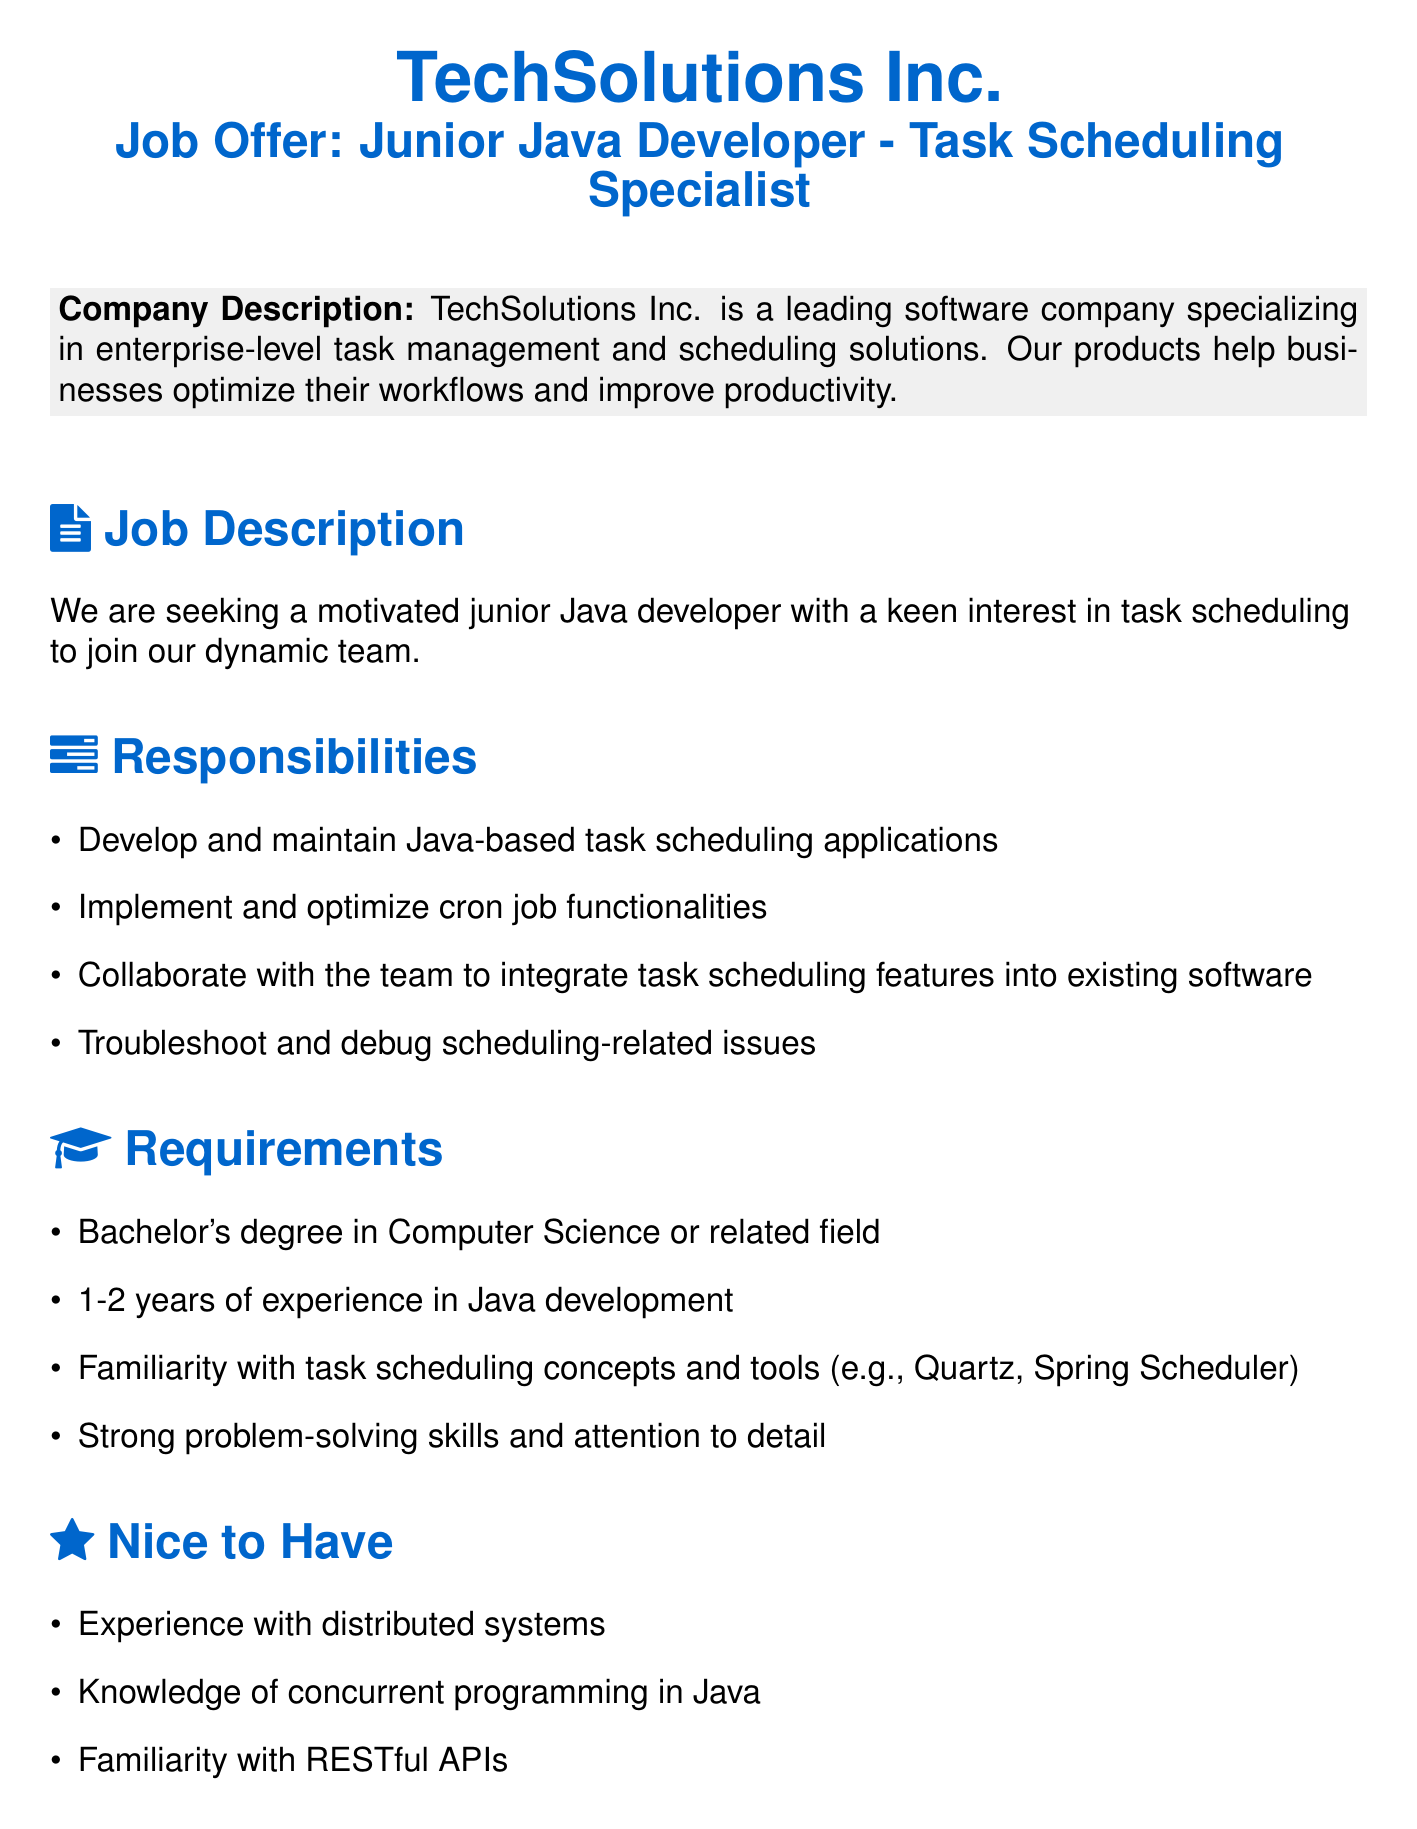what is the job title? The job title is specified in the document as "Junior Java Developer - Task Scheduling Specialist."
Answer: Junior Java Developer - Task Scheduling Specialist how many years of experience is required? The document specifies that 1-2 years of experience in Java development is required for the position.
Answer: 1-2 years what is one of the responsibilities listed? The document lists developing and maintaining Java-based task scheduling applications as one of the responsibilities.
Answer: Develop and maintain Java-based task scheduling applications what company is offering the job? The name of the company offering the job is mentioned at the beginning of the document.
Answer: TechSolutions Inc name one task scheduling tool mentioned in the requirements. The document mentions "Quartz" as one of the task scheduling tools familiar to candidates.
Answer: Quartz what benefit includes 401(k) matching? The benefits section includes a specific mention of 401(k) matching as part of the compensation package.
Answer: 401(k) matching what is the location of the job? The document indicates that the job location is San Francisco, CA.
Answer: San Francisco, CA what educational qualification is required? The document states that a bachelor's degree in Computer Science or a related field is required.
Answer: Bachelor's degree in Computer Science what is a nice-to-have experience for candidates? The document lists experience with distributed systems as a nice to have for candidates applying for the position.
Answer: Experience with distributed systems 